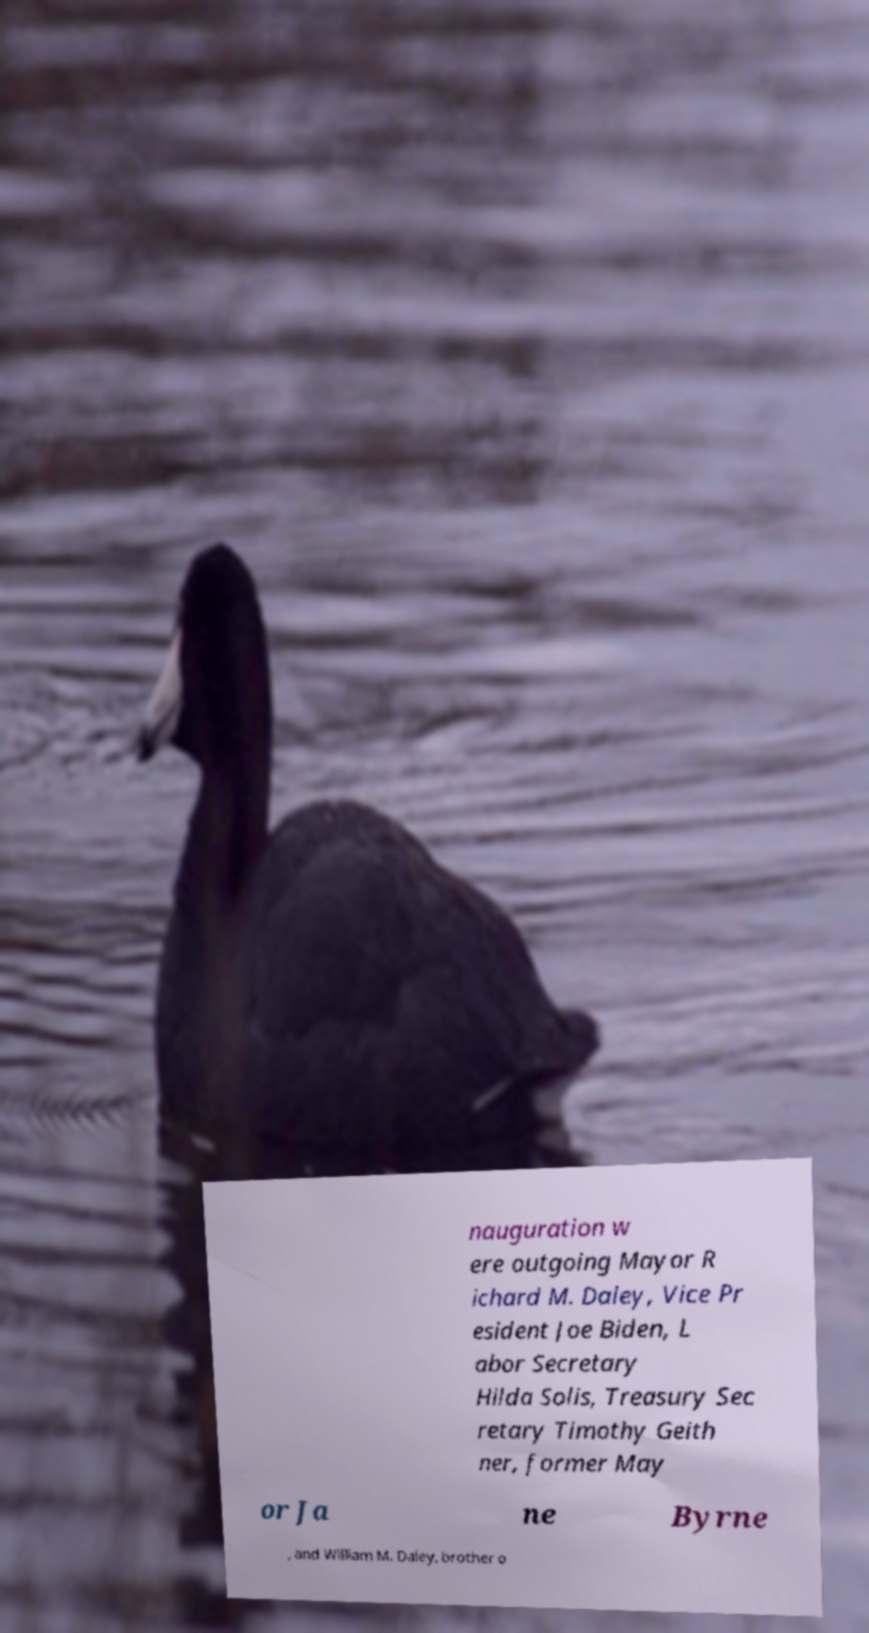There's text embedded in this image that I need extracted. Can you transcribe it verbatim? nauguration w ere outgoing Mayor R ichard M. Daley, Vice Pr esident Joe Biden, L abor Secretary Hilda Solis, Treasury Sec retary Timothy Geith ner, former May or Ja ne Byrne , and William M. Daley, brother o 